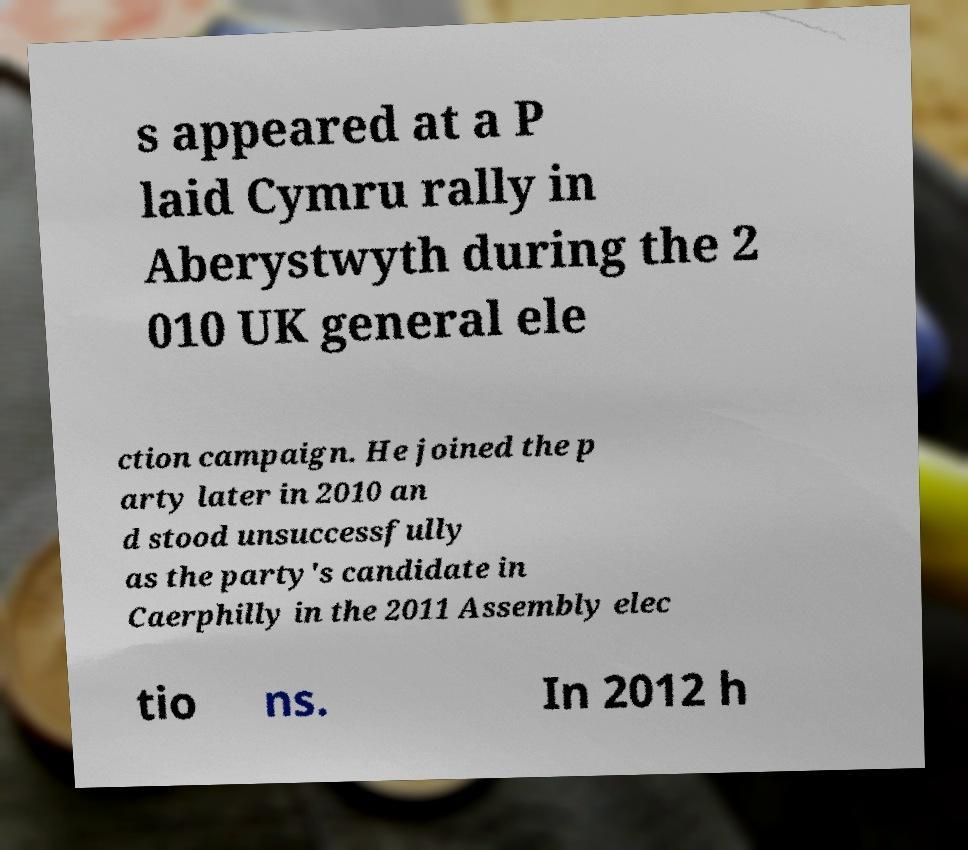Please identify and transcribe the text found in this image. s appeared at a P laid Cymru rally in Aberystwyth during the 2 010 UK general ele ction campaign. He joined the p arty later in 2010 an d stood unsuccessfully as the party's candidate in Caerphilly in the 2011 Assembly elec tio ns. In 2012 h 